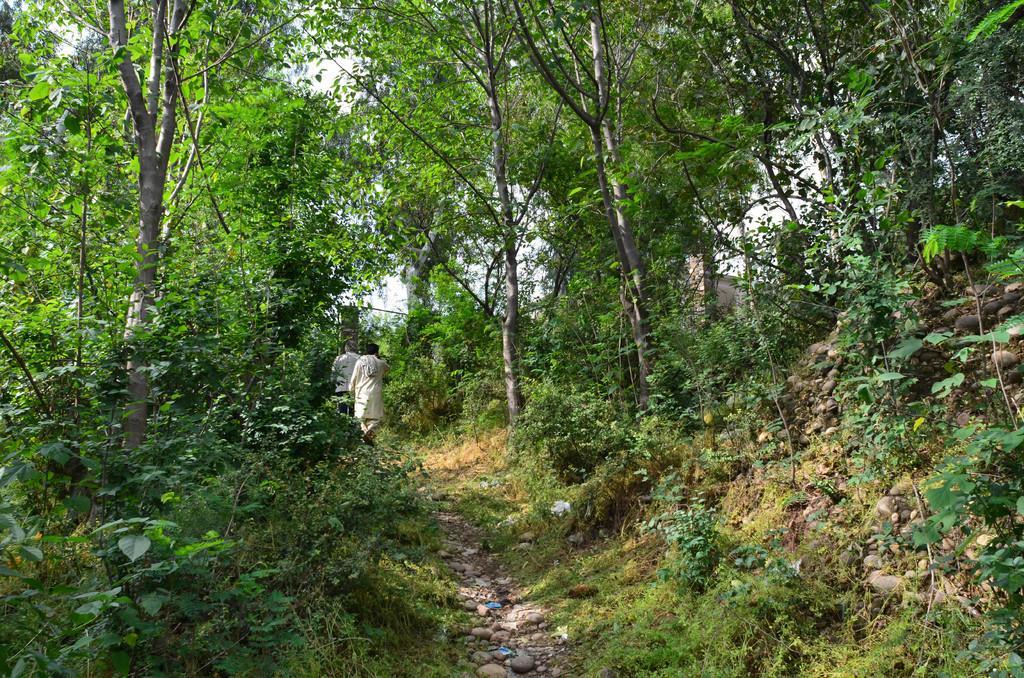In one or two sentences, can you explain what this image depicts? In the foreground of this picture, there is a path and persons walking on the path and on the other side there are plants, trees and the stones are present. In the background, there is the sky. 